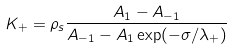Convert formula to latex. <formula><loc_0><loc_0><loc_500><loc_500>K _ { + } = \rho _ { s } \frac { A _ { 1 } - A _ { - 1 } } { A _ { - 1 } - A _ { 1 } \exp ( - \sigma / \lambda _ { + } ) }</formula> 